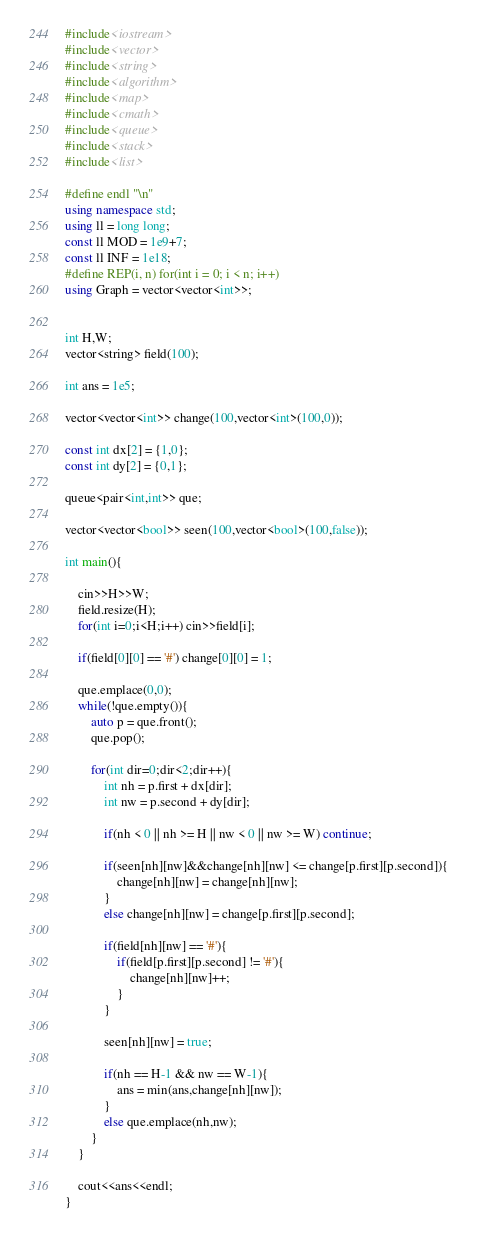Convert code to text. <code><loc_0><loc_0><loc_500><loc_500><_C++_>#include<iostream>
#include<vector>
#include<string>
#include<algorithm>
#include<map>
#include<cmath>
#include<queue>
#include<stack>
#include<list>

#define endl "\n"
using namespace std;
using ll = long long;
const ll MOD = 1e9+7;
const ll INF = 1e18;
#define REP(i, n) for(int i = 0; i < n; i++)
using Graph = vector<vector<int>>;


int H,W;
vector<string> field(100);

int ans = 1e5;

vector<vector<int>> change(100,vector<int>(100,0));

const int dx[2] = {1,0};
const int dy[2] = {0,1};

queue<pair<int,int>> que;

vector<vector<bool>> seen(100,vector<bool>(100,false));

int main(){

    cin>>H>>W;
    field.resize(H);
    for(int i=0;i<H;i++) cin>>field[i];

    if(field[0][0] == '#') change[0][0] = 1;

    que.emplace(0,0);
    while(!que.empty()){
        auto p = que.front();
        que.pop();

        for(int dir=0;dir<2;dir++){
            int nh = p.first + dx[dir];
            int nw = p.second + dy[dir];

            if(nh < 0 || nh >= H || nw < 0 || nw >= W) continue;
            
            if(seen[nh][nw]&&change[nh][nw] <= change[p.first][p.second]){
                change[nh][nw] = change[nh][nw];
            }
            else change[nh][nw] = change[p.first][p.second];

            if(field[nh][nw] == '#'){
                if(field[p.first][p.second] != '#'){
                    change[nh][nw]++;
                }
            }

            seen[nh][nw] = true;

            if(nh == H-1 && nw == W-1){
                ans = min(ans,change[nh][nw]);
            }
            else que.emplace(nh,nw);
        }
    }

    cout<<ans<<endl;
}</code> 